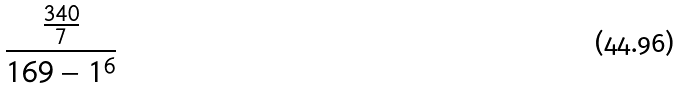<formula> <loc_0><loc_0><loc_500><loc_500>\frac { \frac { 3 4 0 } { 7 } } { 1 6 9 - 1 ^ { 6 } }</formula> 